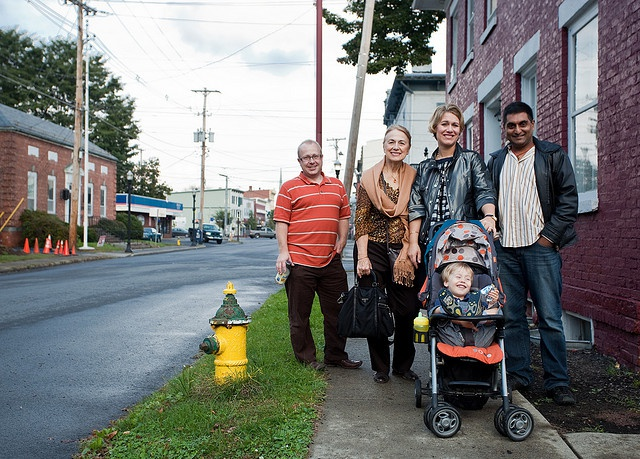Describe the objects in this image and their specific colors. I can see people in lavender, black, lightgray, darkblue, and blue tones, people in lavender, black, tan, brown, and gray tones, people in lavender, black, red, brown, and lightpink tones, people in lavender, black, gray, darkgray, and lightpink tones, and people in lavender, black, gray, darkgray, and navy tones in this image. 